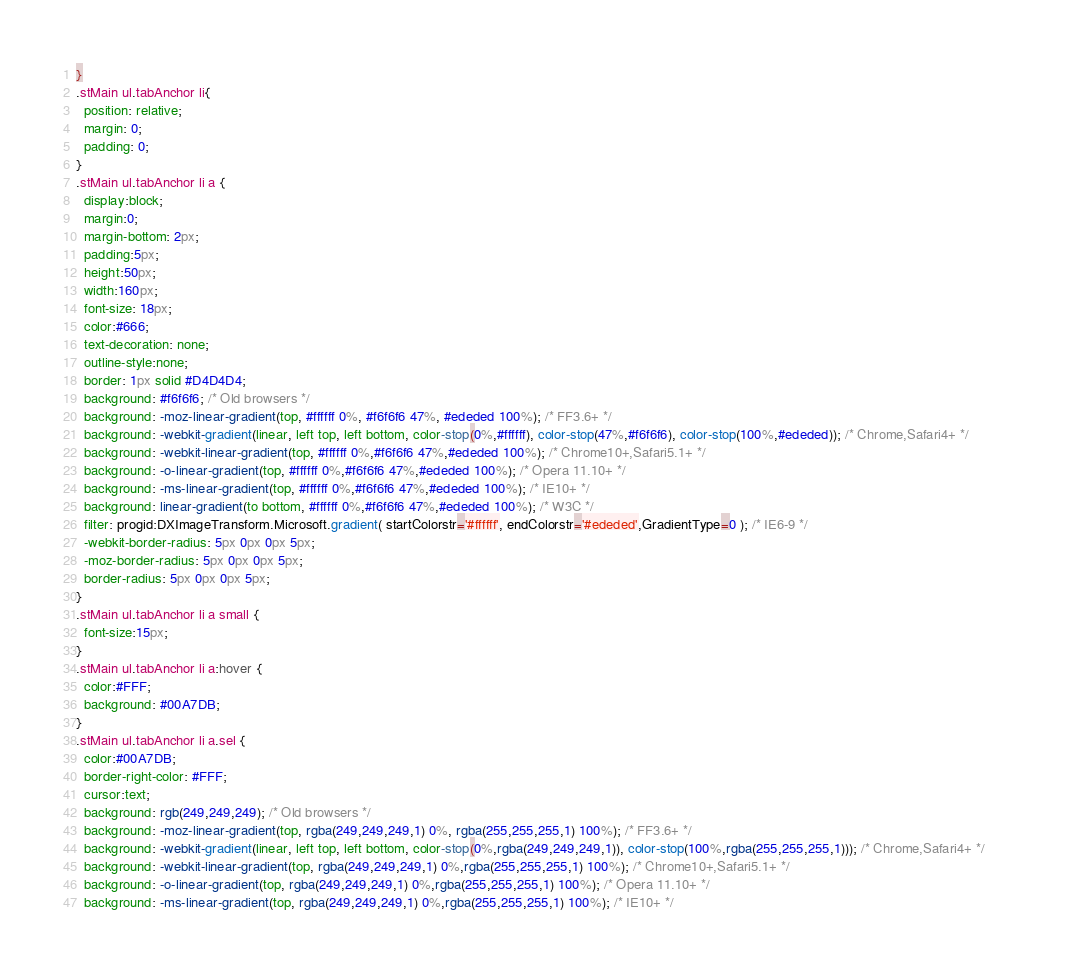<code> <loc_0><loc_0><loc_500><loc_500><_CSS_>}
.stMain ul.tabAnchor li{ 
  position: relative; 
  margin: 0;
  padding: 0;
}
.stMain ul.tabAnchor li a { 
  display:block;
  margin:0;
  margin-bottom: 2px;
  padding:5px;  
  height:50px;
  width:160px;
  font-size: 18px;
  color:#666;
  text-decoration: none;
  outline-style:none;
  border: 1px solid #D4D4D4;
  background: #f6f6f6; /* Old browsers */
  background: -moz-linear-gradient(top, #ffffff 0%, #f6f6f6 47%, #ededed 100%); /* FF3.6+ */                                                                                
  background: -webkit-gradient(linear, left top, left bottom, color-stop(0%,#ffffff), color-stop(47%,#f6f6f6), color-stop(100%,#ededed)); /* Chrome,Safari4+ */             
  background: -webkit-linear-gradient(top, #ffffff 0%,#f6f6f6 47%,#ededed 100%); /* Chrome10+,Safari5.1+ */                                                                 
  background: -o-linear-gradient(top, #ffffff 0%,#f6f6f6 47%,#ededed 100%); /* Opera 11.10+ */                                                                              
  background: -ms-linear-gradient(top, #ffffff 0%,#f6f6f6 47%,#ededed 100%); /* IE10+ */                                                                                    
  background: linear-gradient(to bottom, #ffffff 0%,#f6f6f6 47%,#ededed 100%); /* W3C */                                                                                    
  filter: progid:DXImageTransform.Microsoft.gradient( startColorstr='#ffffff', endColorstr='#ededed',GradientType=0 ); /* IE6-9 */  
  -webkit-border-radius: 5px 0px 0px 5px;
  -moz-border-radius: 5px 0px 0px 5px;
  border-radius: 5px 0px 0px 5px;  
}
.stMain ul.tabAnchor li a small {
  font-size:15px;
}
.stMain ul.tabAnchor li a:hover {
  color:#FFF;
  background: #00A7DB;
}
.stMain ul.tabAnchor li a.sel {
  color:#00A7DB;
  border-right-color: #FFF;
  cursor:text;
  background: rgb(249,249,249); /* Old browsers */
  background: -moz-linear-gradient(top, rgba(249,249,249,1) 0%, rgba(255,255,255,1) 100%); /* FF3.6+ */
  background: -webkit-gradient(linear, left top, left bottom, color-stop(0%,rgba(249,249,249,1)), color-stop(100%,rgba(255,255,255,1))); /* Chrome,Safari4+ */
  background: -webkit-linear-gradient(top, rgba(249,249,249,1) 0%,rgba(255,255,255,1) 100%); /* Chrome10+,Safari5.1+ */
  background: -o-linear-gradient(top, rgba(249,249,249,1) 0%,rgba(255,255,255,1) 100%); /* Opera 11.10+ */
  background: -ms-linear-gradient(top, rgba(249,249,249,1) 0%,rgba(255,255,255,1) 100%); /* IE10+ */</code> 